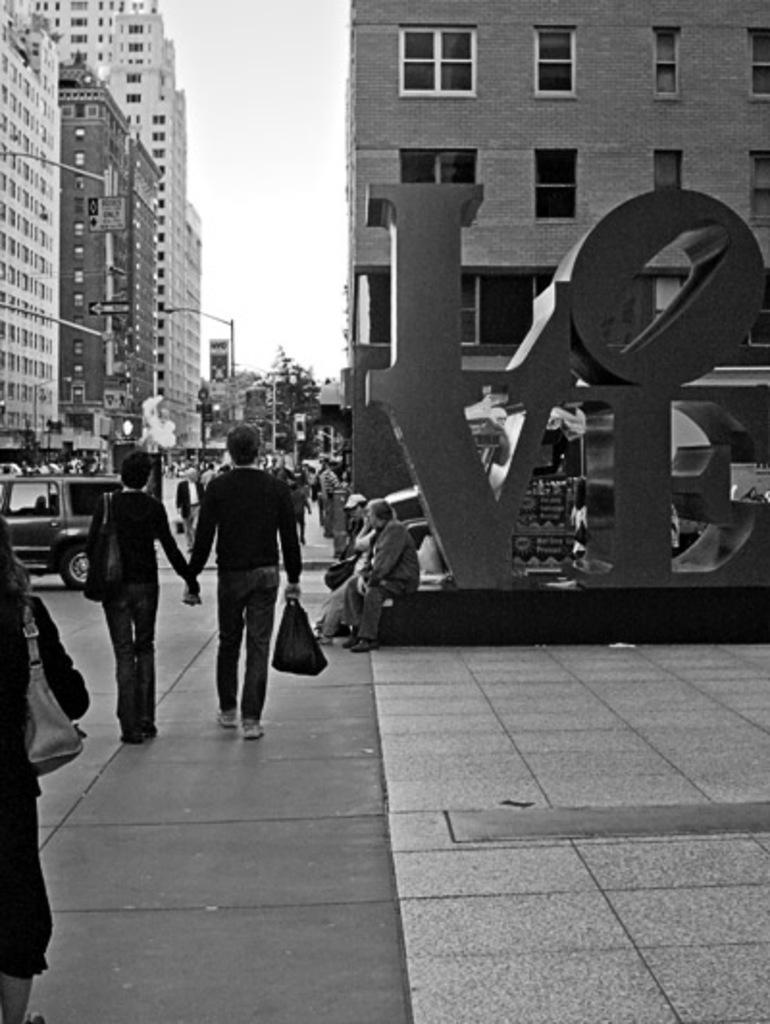Please provide a concise description of this image. This is a black and white image. In this image we can see buildings, sculptures, people on the road, motor vehicles, street poles, street lights, trees and sky. 